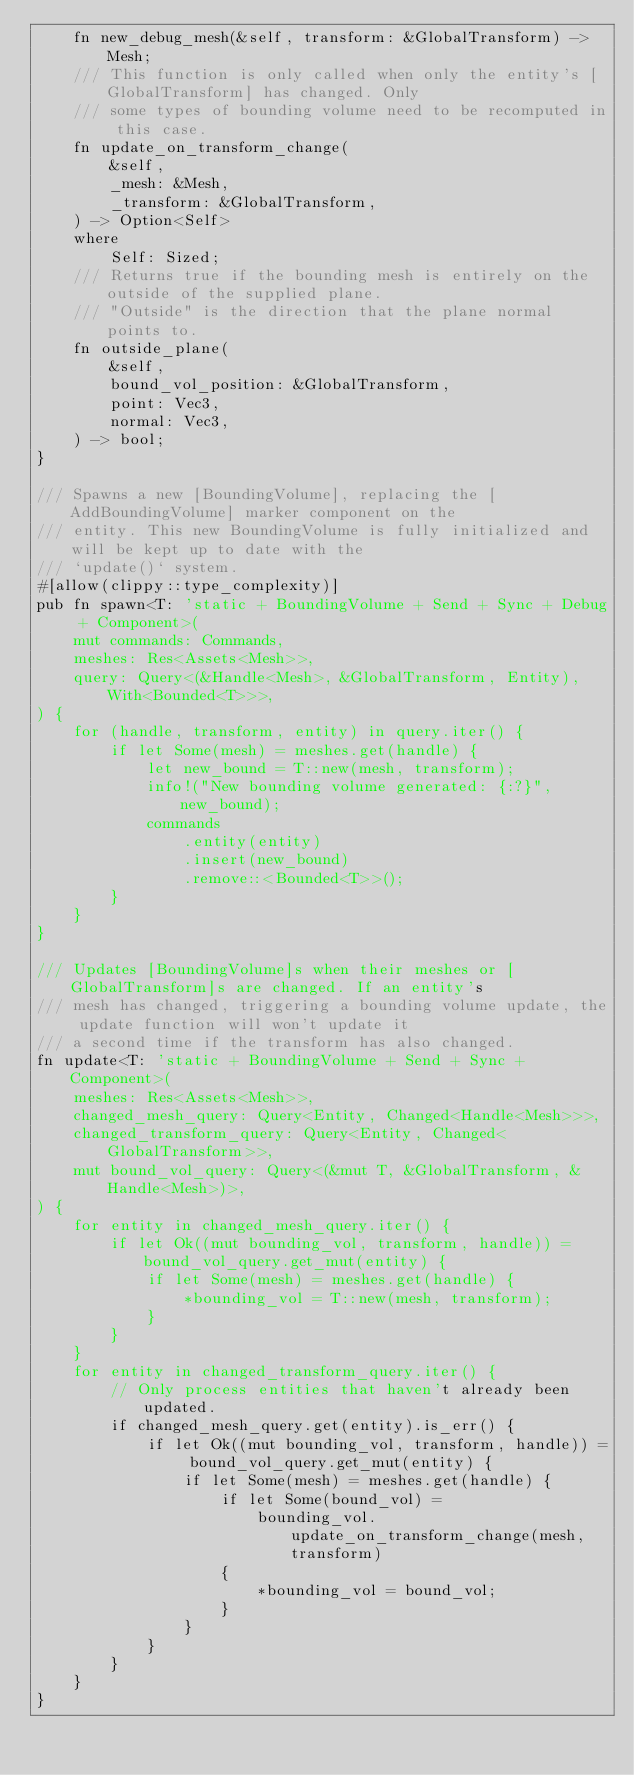<code> <loc_0><loc_0><loc_500><loc_500><_Rust_>    fn new_debug_mesh(&self, transform: &GlobalTransform) -> Mesh;
    /// This function is only called when only the entity's [GlobalTransform] has changed. Only
    /// some types of bounding volume need to be recomputed in this case.
    fn update_on_transform_change(
        &self,
        _mesh: &Mesh,
        _transform: &GlobalTransform,
    ) -> Option<Self>
    where
        Self: Sized;
    /// Returns true if the bounding mesh is entirely on the outside of the supplied plane.
    /// "Outside" is the direction that the plane normal points to.
    fn outside_plane(
        &self,
        bound_vol_position: &GlobalTransform,
        point: Vec3,
        normal: Vec3,
    ) -> bool;
}

/// Spawns a new [BoundingVolume], replacing the [AddBoundingVolume] marker component on the
/// entity. This new BoundingVolume is fully initialized and will be kept up to date with the
/// `update()` system.
#[allow(clippy::type_complexity)]
pub fn spawn<T: 'static + BoundingVolume + Send + Sync + Debug + Component>(
    mut commands: Commands,
    meshes: Res<Assets<Mesh>>,
    query: Query<(&Handle<Mesh>, &GlobalTransform, Entity), With<Bounded<T>>>,
) {
    for (handle, transform, entity) in query.iter() {
        if let Some(mesh) = meshes.get(handle) {
            let new_bound = T::new(mesh, transform);
            info!("New bounding volume generated: {:?}", new_bound);
            commands
                .entity(entity)
                .insert(new_bound)
                .remove::<Bounded<T>>();
        }
    }
}

/// Updates [BoundingVolume]s when their meshes or [GlobalTransform]s are changed. If an entity's
/// mesh has changed, triggering a bounding volume update, the update function will won't update it
/// a second time if the transform has also changed.
fn update<T: 'static + BoundingVolume + Send + Sync + Component>(
    meshes: Res<Assets<Mesh>>,
    changed_mesh_query: Query<Entity, Changed<Handle<Mesh>>>,
    changed_transform_query: Query<Entity, Changed<GlobalTransform>>,
    mut bound_vol_query: Query<(&mut T, &GlobalTransform, &Handle<Mesh>)>,
) {
    for entity in changed_mesh_query.iter() {
        if let Ok((mut bounding_vol, transform, handle)) = bound_vol_query.get_mut(entity) {
            if let Some(mesh) = meshes.get(handle) {
                *bounding_vol = T::new(mesh, transform);
            }
        }
    }
    for entity in changed_transform_query.iter() {
        // Only process entities that haven't already been updated.
        if changed_mesh_query.get(entity).is_err() {
            if let Ok((mut bounding_vol, transform, handle)) = bound_vol_query.get_mut(entity) {
                if let Some(mesh) = meshes.get(handle) {
                    if let Some(bound_vol) =
                        bounding_vol.update_on_transform_change(mesh, transform)
                    {
                        *bounding_vol = bound_vol;
                    }
                }
            }
        }
    }
}
</code> 